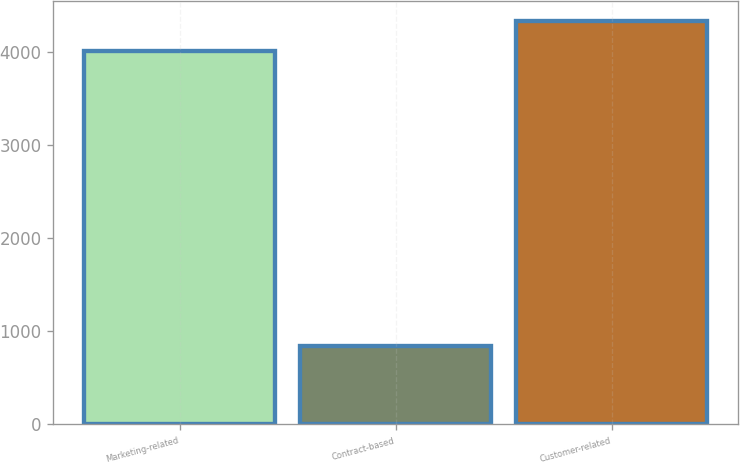<chart> <loc_0><loc_0><loc_500><loc_500><bar_chart><fcel>Marketing-related<fcel>Contract-based<fcel>Customer-related<nl><fcel>4016<fcel>841<fcel>4336.4<nl></chart> 